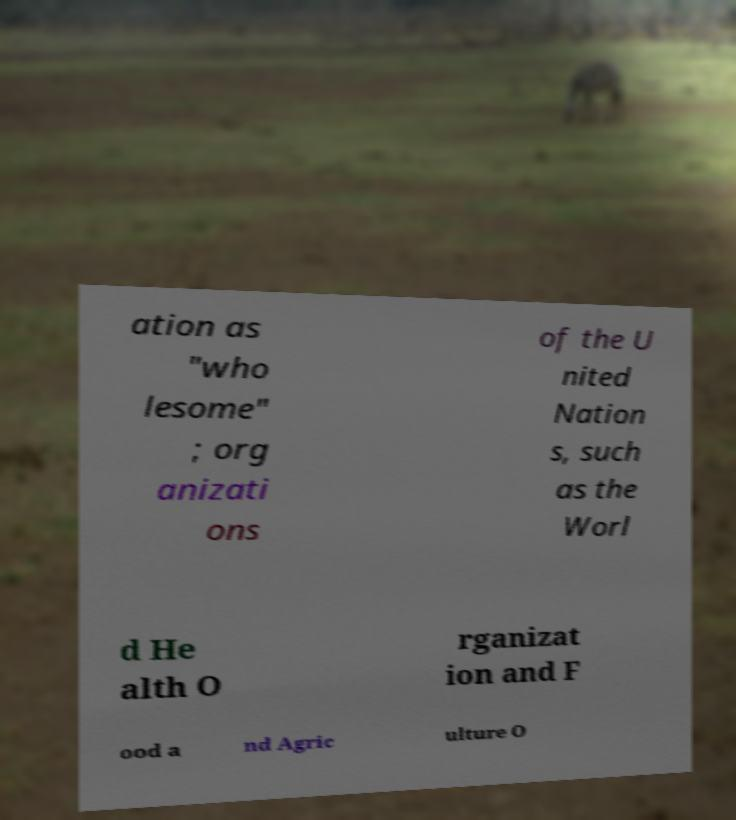Can you read and provide the text displayed in the image?This photo seems to have some interesting text. Can you extract and type it out for me? ation as "who lesome" ; org anizati ons of the U nited Nation s, such as the Worl d He alth O rganizat ion and F ood a nd Agric ulture O 